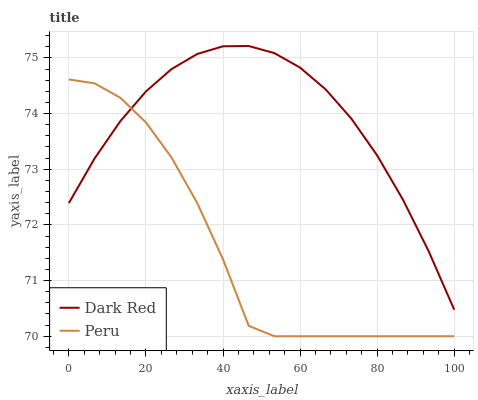Does Peru have the minimum area under the curve?
Answer yes or no. Yes. Does Dark Red have the maximum area under the curve?
Answer yes or no. Yes. Does Peru have the maximum area under the curve?
Answer yes or no. No. Is Dark Red the smoothest?
Answer yes or no. Yes. Is Peru the roughest?
Answer yes or no. Yes. Is Peru the smoothest?
Answer yes or no. No. Does Peru have the highest value?
Answer yes or no. No. 